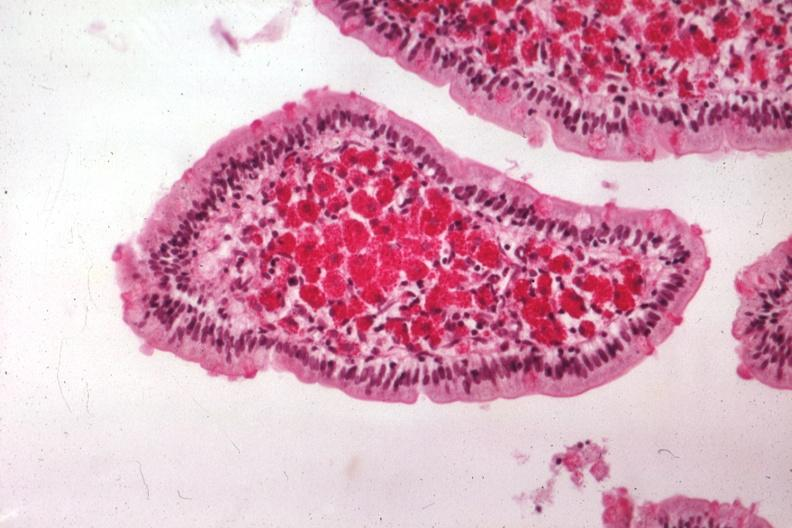what is present?
Answer the question using a single word or phrase. Gastrointestinal 